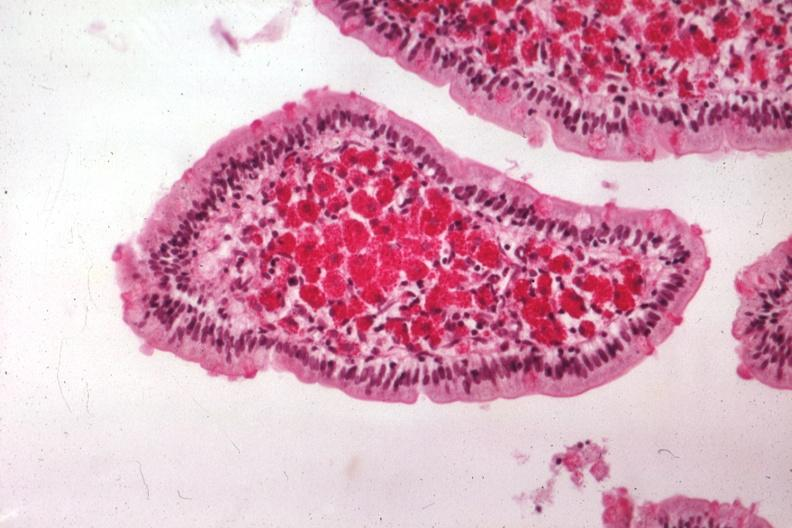what is present?
Answer the question using a single word or phrase. Gastrointestinal 